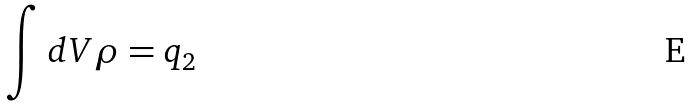Convert formula to latex. <formula><loc_0><loc_0><loc_500><loc_500>\int d V \rho = q _ { 2 }</formula> 